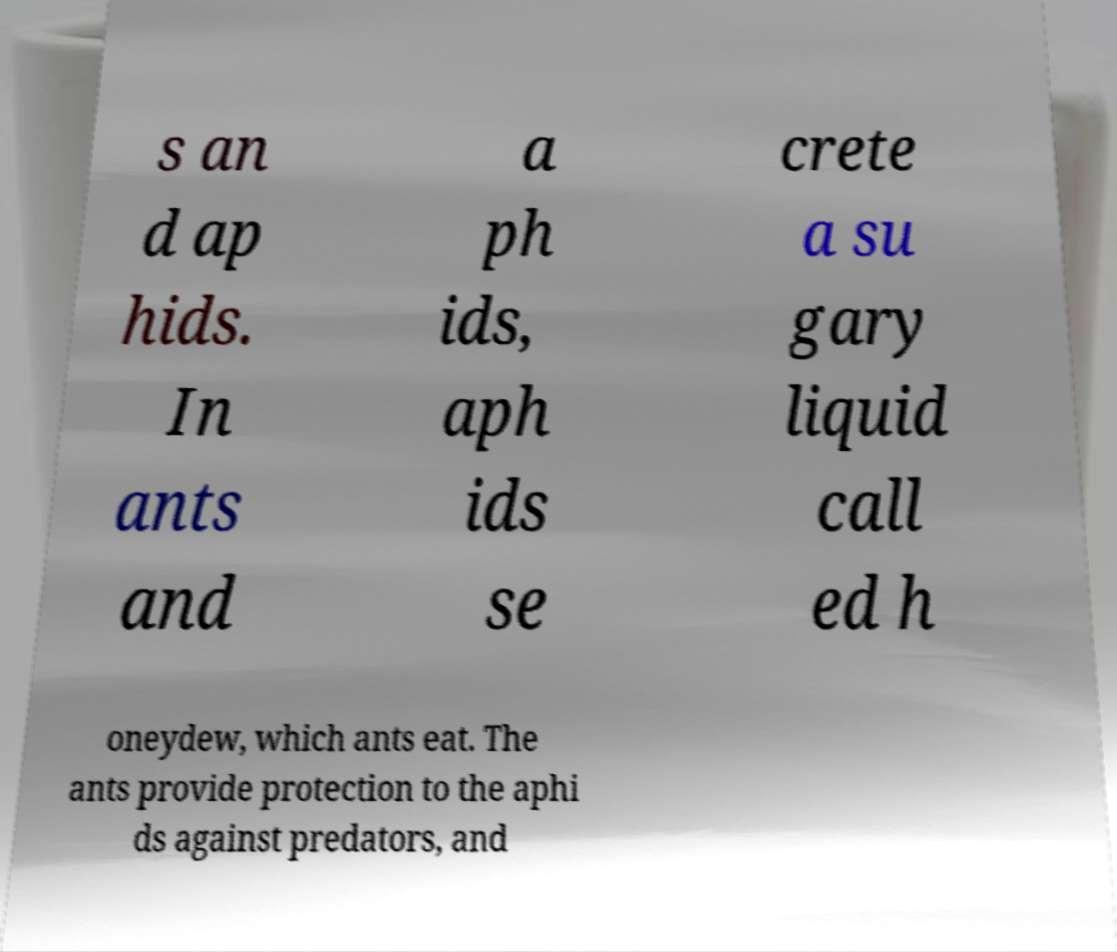I need the written content from this picture converted into text. Can you do that? s an d ap hids. In ants and a ph ids, aph ids se crete a su gary liquid call ed h oneydew, which ants eat. The ants provide protection to the aphi ds against predators, and 